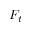Convert formula to latex. <formula><loc_0><loc_0><loc_500><loc_500>F _ { t }</formula> 